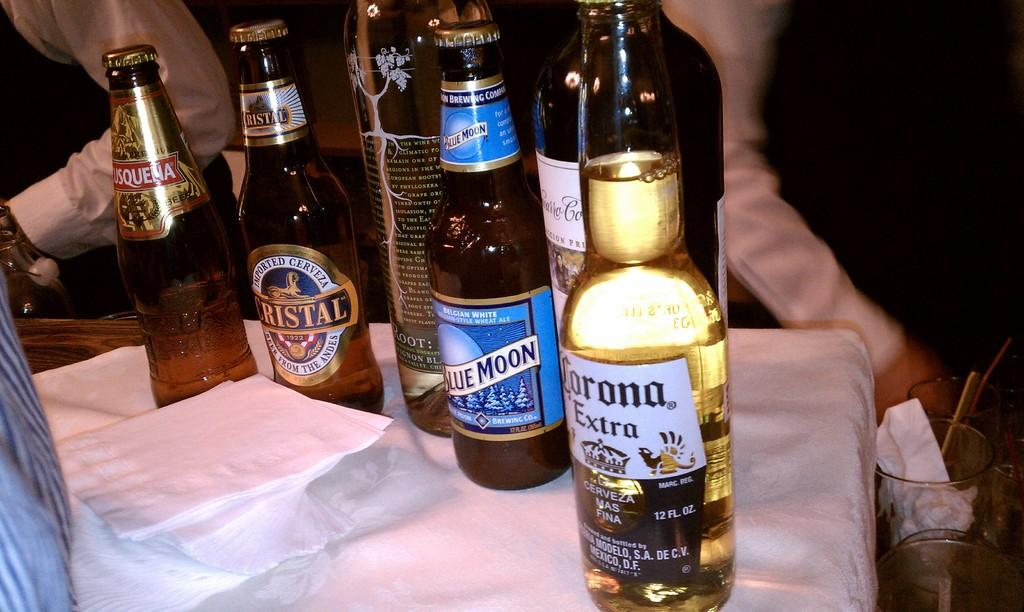What objects are on the white color surface in the image? There are bottles on a white color surface in the image. Can you describe the people visible in the background of the image? The provided facts do not give a description of the people visible in the background. What is located on the right side of the image? There are glasses and other objects on the right side of the image. What type of loaf is being used as a table in the image? There is no loaf present in the image, and the surface is described as white, not a loaf. What is the weather like in the image? The provided facts do not give any information about the weather in the image. 